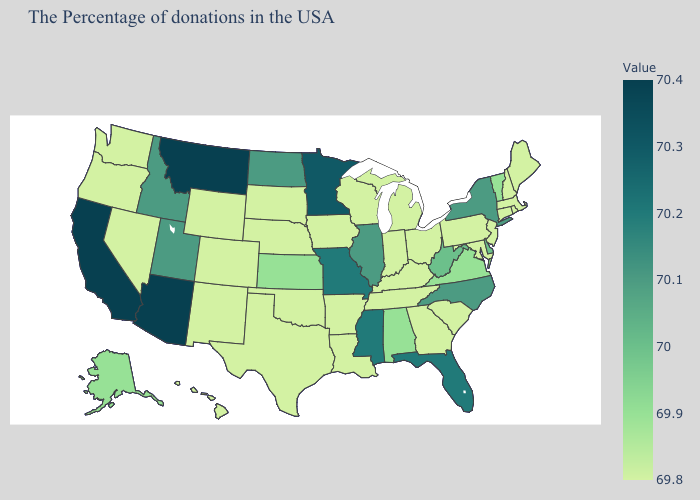Does Minnesota have the highest value in the MidWest?
Be succinct. Yes. Which states have the highest value in the USA?
Write a very short answer. Montana, Arizona, California. Is the legend a continuous bar?
Write a very short answer. Yes. Is the legend a continuous bar?
Give a very brief answer. Yes. Does California have a higher value than Iowa?
Keep it brief. Yes. 